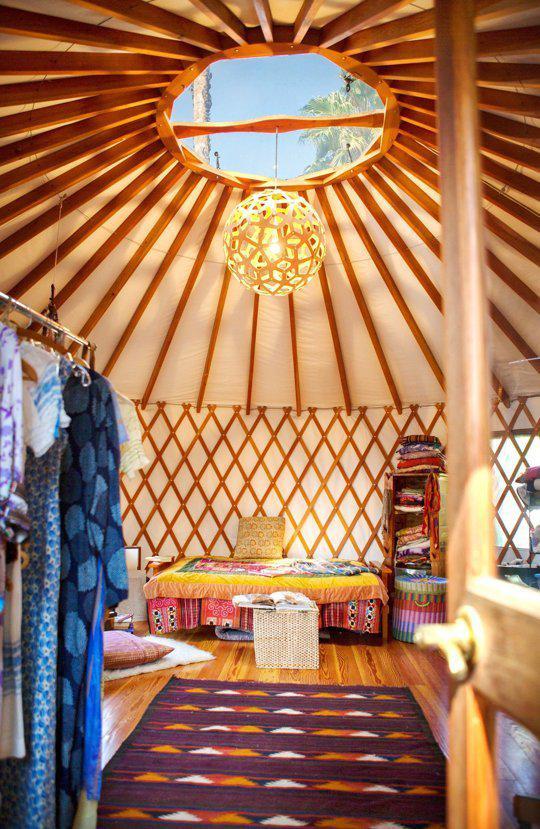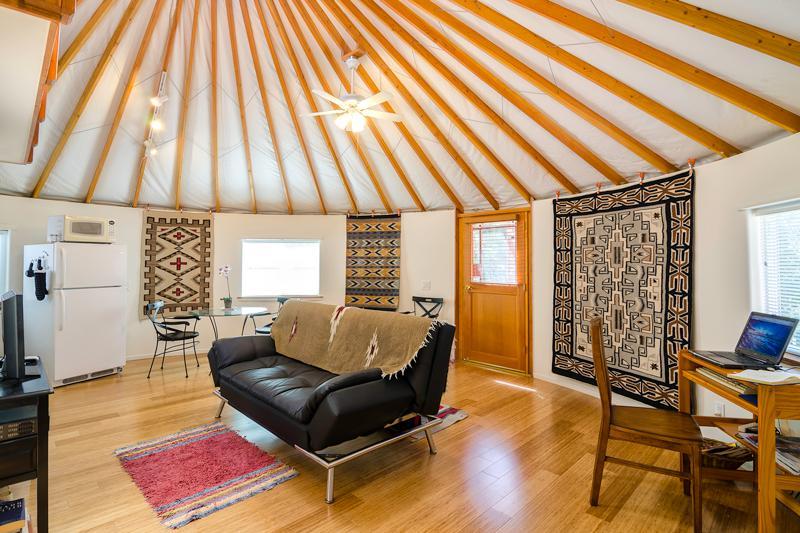The first image is the image on the left, the second image is the image on the right. Assess this claim about the two images: "There are at least two stools in one of the images.". Correct or not? Answer yes or no. No. The first image is the image on the left, the second image is the image on the right. Given the left and right images, does the statement "There is exactly one ceiling fan in the image on the right." hold true? Answer yes or no. Yes. 